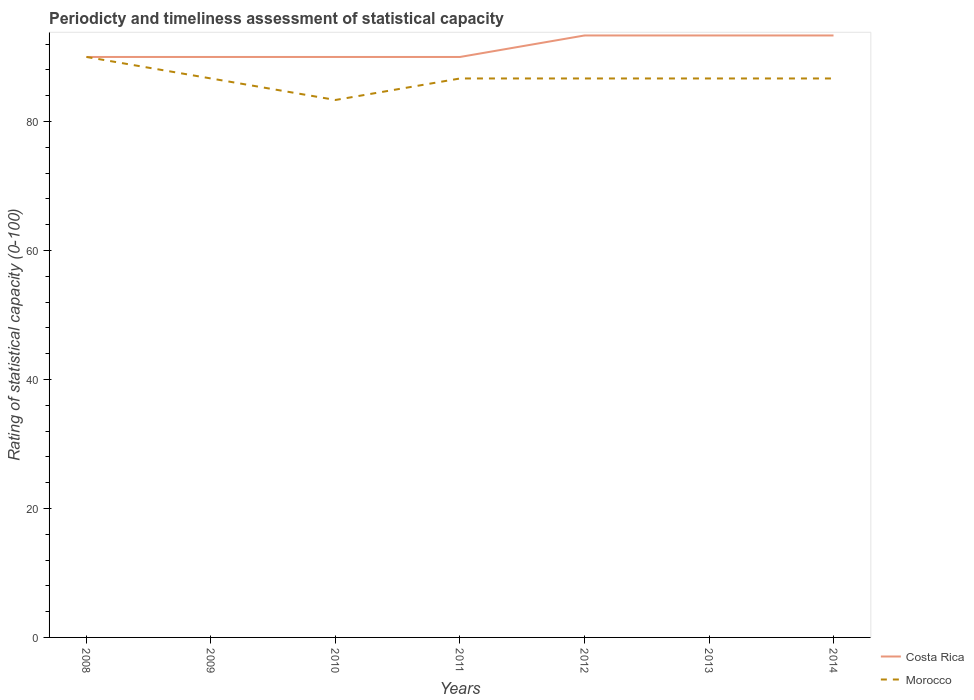Does the line corresponding to Morocco intersect with the line corresponding to Costa Rica?
Offer a very short reply. Yes. Across all years, what is the maximum rating of statistical capacity in Costa Rica?
Offer a very short reply. 90. What is the difference between the highest and the second highest rating of statistical capacity in Morocco?
Offer a terse response. 6.67. How many lines are there?
Your answer should be very brief. 2. How many years are there in the graph?
Keep it short and to the point. 7. Does the graph contain any zero values?
Ensure brevity in your answer.  No. How many legend labels are there?
Ensure brevity in your answer.  2. What is the title of the graph?
Your response must be concise. Periodicty and timeliness assessment of statistical capacity. Does "South Asia" appear as one of the legend labels in the graph?
Give a very brief answer. No. What is the label or title of the Y-axis?
Your response must be concise. Rating of statistical capacity (0-100). What is the Rating of statistical capacity (0-100) of Morocco in 2009?
Keep it short and to the point. 86.67. What is the Rating of statistical capacity (0-100) in Costa Rica in 2010?
Keep it short and to the point. 90. What is the Rating of statistical capacity (0-100) of Morocco in 2010?
Make the answer very short. 83.33. What is the Rating of statistical capacity (0-100) of Morocco in 2011?
Provide a succinct answer. 86.67. What is the Rating of statistical capacity (0-100) in Costa Rica in 2012?
Keep it short and to the point. 93.33. What is the Rating of statistical capacity (0-100) in Morocco in 2012?
Your answer should be compact. 86.67. What is the Rating of statistical capacity (0-100) of Costa Rica in 2013?
Provide a succinct answer. 93.33. What is the Rating of statistical capacity (0-100) in Morocco in 2013?
Your response must be concise. 86.67. What is the Rating of statistical capacity (0-100) in Costa Rica in 2014?
Offer a very short reply. 93.33. What is the Rating of statistical capacity (0-100) of Morocco in 2014?
Your response must be concise. 86.67. Across all years, what is the maximum Rating of statistical capacity (0-100) in Costa Rica?
Keep it short and to the point. 93.33. Across all years, what is the maximum Rating of statistical capacity (0-100) in Morocco?
Your answer should be compact. 90. Across all years, what is the minimum Rating of statistical capacity (0-100) in Morocco?
Offer a very short reply. 83.33. What is the total Rating of statistical capacity (0-100) of Costa Rica in the graph?
Make the answer very short. 640. What is the total Rating of statistical capacity (0-100) of Morocco in the graph?
Your response must be concise. 606.67. What is the difference between the Rating of statistical capacity (0-100) in Costa Rica in 2008 and that in 2010?
Give a very brief answer. 0. What is the difference between the Rating of statistical capacity (0-100) in Costa Rica in 2008 and that in 2011?
Make the answer very short. 0. What is the difference between the Rating of statistical capacity (0-100) of Costa Rica in 2008 and that in 2012?
Ensure brevity in your answer.  -3.33. What is the difference between the Rating of statistical capacity (0-100) in Morocco in 2008 and that in 2014?
Provide a succinct answer. 3.33. What is the difference between the Rating of statistical capacity (0-100) in Costa Rica in 2009 and that in 2010?
Ensure brevity in your answer.  0. What is the difference between the Rating of statistical capacity (0-100) of Costa Rica in 2009 and that in 2011?
Your answer should be very brief. 0. What is the difference between the Rating of statistical capacity (0-100) of Morocco in 2009 and that in 2011?
Keep it short and to the point. 0. What is the difference between the Rating of statistical capacity (0-100) in Morocco in 2009 and that in 2012?
Make the answer very short. 0. What is the difference between the Rating of statistical capacity (0-100) in Morocco in 2009 and that in 2013?
Keep it short and to the point. 0. What is the difference between the Rating of statistical capacity (0-100) of Morocco in 2009 and that in 2014?
Keep it short and to the point. 0. What is the difference between the Rating of statistical capacity (0-100) in Costa Rica in 2010 and that in 2011?
Provide a short and direct response. 0. What is the difference between the Rating of statistical capacity (0-100) of Morocco in 2010 and that in 2011?
Provide a succinct answer. -3.33. What is the difference between the Rating of statistical capacity (0-100) in Costa Rica in 2010 and that in 2012?
Your response must be concise. -3.33. What is the difference between the Rating of statistical capacity (0-100) in Morocco in 2010 and that in 2012?
Make the answer very short. -3.33. What is the difference between the Rating of statistical capacity (0-100) in Costa Rica in 2010 and that in 2013?
Provide a succinct answer. -3.33. What is the difference between the Rating of statistical capacity (0-100) in Morocco in 2010 and that in 2014?
Ensure brevity in your answer.  -3.33. What is the difference between the Rating of statistical capacity (0-100) of Morocco in 2011 and that in 2012?
Your response must be concise. 0. What is the difference between the Rating of statistical capacity (0-100) in Costa Rica in 2011 and that in 2013?
Provide a succinct answer. -3.33. What is the difference between the Rating of statistical capacity (0-100) in Morocco in 2011 and that in 2013?
Provide a short and direct response. 0. What is the difference between the Rating of statistical capacity (0-100) of Costa Rica in 2011 and that in 2014?
Ensure brevity in your answer.  -3.33. What is the difference between the Rating of statistical capacity (0-100) in Costa Rica in 2012 and that in 2014?
Make the answer very short. -0. What is the difference between the Rating of statistical capacity (0-100) in Costa Rica in 2013 and that in 2014?
Provide a succinct answer. 0. What is the difference between the Rating of statistical capacity (0-100) of Morocco in 2013 and that in 2014?
Your response must be concise. 0. What is the difference between the Rating of statistical capacity (0-100) in Costa Rica in 2008 and the Rating of statistical capacity (0-100) in Morocco in 2009?
Provide a succinct answer. 3.33. What is the difference between the Rating of statistical capacity (0-100) of Costa Rica in 2008 and the Rating of statistical capacity (0-100) of Morocco in 2011?
Your answer should be very brief. 3.33. What is the difference between the Rating of statistical capacity (0-100) of Costa Rica in 2008 and the Rating of statistical capacity (0-100) of Morocco in 2012?
Your answer should be compact. 3.33. What is the difference between the Rating of statistical capacity (0-100) in Costa Rica in 2008 and the Rating of statistical capacity (0-100) in Morocco in 2014?
Offer a very short reply. 3.33. What is the difference between the Rating of statistical capacity (0-100) in Costa Rica in 2009 and the Rating of statistical capacity (0-100) in Morocco in 2010?
Offer a terse response. 6.67. What is the difference between the Rating of statistical capacity (0-100) in Costa Rica in 2009 and the Rating of statistical capacity (0-100) in Morocco in 2013?
Ensure brevity in your answer.  3.33. What is the difference between the Rating of statistical capacity (0-100) of Costa Rica in 2010 and the Rating of statistical capacity (0-100) of Morocco in 2011?
Keep it short and to the point. 3.33. What is the difference between the Rating of statistical capacity (0-100) in Costa Rica in 2010 and the Rating of statistical capacity (0-100) in Morocco in 2012?
Make the answer very short. 3.33. What is the difference between the Rating of statistical capacity (0-100) of Costa Rica in 2010 and the Rating of statistical capacity (0-100) of Morocco in 2014?
Offer a very short reply. 3.33. What is the difference between the Rating of statistical capacity (0-100) in Costa Rica in 2011 and the Rating of statistical capacity (0-100) in Morocco in 2012?
Give a very brief answer. 3.33. What is the difference between the Rating of statistical capacity (0-100) in Costa Rica in 2011 and the Rating of statistical capacity (0-100) in Morocco in 2013?
Provide a succinct answer. 3.33. What is the difference between the Rating of statistical capacity (0-100) in Costa Rica in 2012 and the Rating of statistical capacity (0-100) in Morocco in 2013?
Provide a succinct answer. 6.67. What is the average Rating of statistical capacity (0-100) in Costa Rica per year?
Give a very brief answer. 91.43. What is the average Rating of statistical capacity (0-100) in Morocco per year?
Your answer should be compact. 86.67. In the year 2008, what is the difference between the Rating of statistical capacity (0-100) in Costa Rica and Rating of statistical capacity (0-100) in Morocco?
Your response must be concise. 0. In the year 2012, what is the difference between the Rating of statistical capacity (0-100) in Costa Rica and Rating of statistical capacity (0-100) in Morocco?
Offer a terse response. 6.67. In the year 2013, what is the difference between the Rating of statistical capacity (0-100) of Costa Rica and Rating of statistical capacity (0-100) of Morocco?
Your answer should be compact. 6.67. In the year 2014, what is the difference between the Rating of statistical capacity (0-100) of Costa Rica and Rating of statistical capacity (0-100) of Morocco?
Keep it short and to the point. 6.67. What is the ratio of the Rating of statistical capacity (0-100) in Morocco in 2008 to that in 2009?
Your answer should be very brief. 1.04. What is the ratio of the Rating of statistical capacity (0-100) of Costa Rica in 2008 to that in 2010?
Offer a very short reply. 1. What is the ratio of the Rating of statistical capacity (0-100) of Morocco in 2008 to that in 2011?
Provide a short and direct response. 1.04. What is the ratio of the Rating of statistical capacity (0-100) of Costa Rica in 2008 to that in 2012?
Offer a very short reply. 0.96. What is the ratio of the Rating of statistical capacity (0-100) in Morocco in 2008 to that in 2012?
Offer a very short reply. 1.04. What is the ratio of the Rating of statistical capacity (0-100) in Costa Rica in 2008 to that in 2014?
Your response must be concise. 0.96. What is the ratio of the Rating of statistical capacity (0-100) in Morocco in 2008 to that in 2014?
Keep it short and to the point. 1.04. What is the ratio of the Rating of statistical capacity (0-100) in Costa Rica in 2009 to that in 2010?
Your answer should be compact. 1. What is the ratio of the Rating of statistical capacity (0-100) of Morocco in 2009 to that in 2010?
Keep it short and to the point. 1.04. What is the ratio of the Rating of statistical capacity (0-100) of Costa Rica in 2009 to that in 2011?
Your response must be concise. 1. What is the ratio of the Rating of statistical capacity (0-100) in Morocco in 2009 to that in 2011?
Provide a short and direct response. 1. What is the ratio of the Rating of statistical capacity (0-100) in Costa Rica in 2009 to that in 2012?
Your response must be concise. 0.96. What is the ratio of the Rating of statistical capacity (0-100) in Morocco in 2009 to that in 2012?
Your response must be concise. 1. What is the ratio of the Rating of statistical capacity (0-100) of Morocco in 2009 to that in 2013?
Make the answer very short. 1. What is the ratio of the Rating of statistical capacity (0-100) of Costa Rica in 2009 to that in 2014?
Provide a succinct answer. 0.96. What is the ratio of the Rating of statistical capacity (0-100) of Morocco in 2009 to that in 2014?
Keep it short and to the point. 1. What is the ratio of the Rating of statistical capacity (0-100) of Morocco in 2010 to that in 2011?
Offer a terse response. 0.96. What is the ratio of the Rating of statistical capacity (0-100) in Costa Rica in 2010 to that in 2012?
Provide a short and direct response. 0.96. What is the ratio of the Rating of statistical capacity (0-100) in Morocco in 2010 to that in 2012?
Provide a succinct answer. 0.96. What is the ratio of the Rating of statistical capacity (0-100) of Costa Rica in 2010 to that in 2013?
Your answer should be compact. 0.96. What is the ratio of the Rating of statistical capacity (0-100) of Morocco in 2010 to that in 2013?
Make the answer very short. 0.96. What is the ratio of the Rating of statistical capacity (0-100) of Morocco in 2010 to that in 2014?
Provide a short and direct response. 0.96. What is the ratio of the Rating of statistical capacity (0-100) of Costa Rica in 2011 to that in 2012?
Offer a very short reply. 0.96. What is the ratio of the Rating of statistical capacity (0-100) in Morocco in 2011 to that in 2012?
Ensure brevity in your answer.  1. What is the ratio of the Rating of statistical capacity (0-100) in Morocco in 2011 to that in 2013?
Make the answer very short. 1. What is the ratio of the Rating of statistical capacity (0-100) in Costa Rica in 2012 to that in 2013?
Your response must be concise. 1. What is the ratio of the Rating of statistical capacity (0-100) of Costa Rica in 2013 to that in 2014?
Your answer should be compact. 1. 